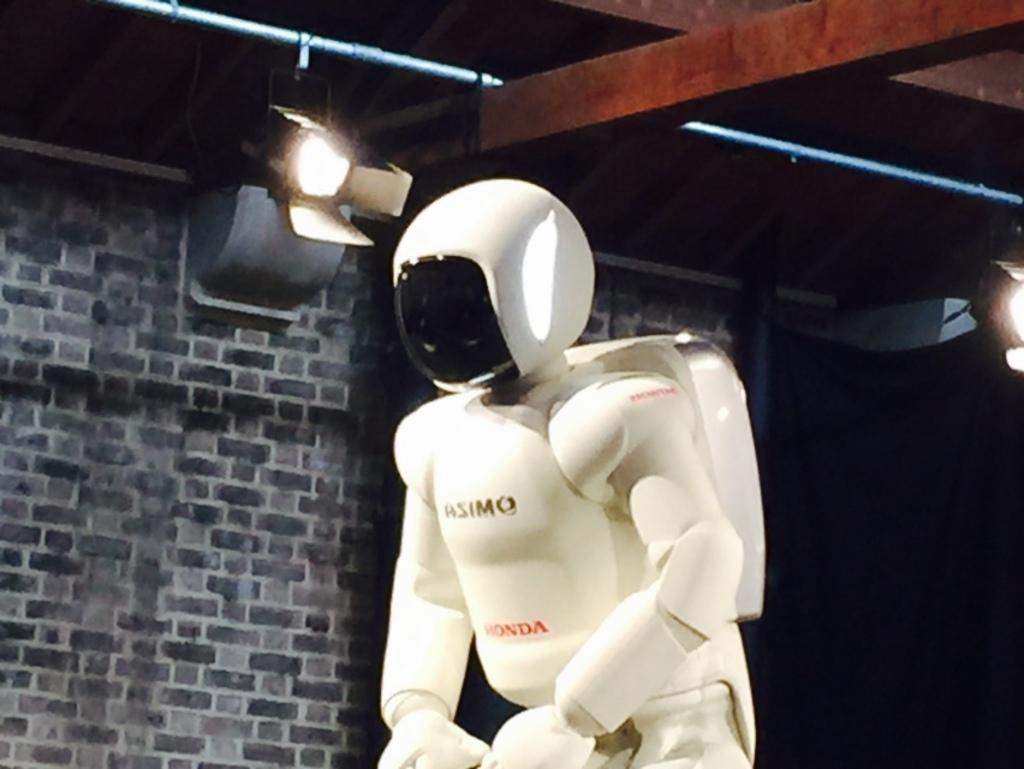What is the main subject of the image? There is a white color robot in the image. Where is the robot located in the image? The robot is in the middle of the image. What can be seen in the background of the image? There is a wall in the background of the image. What is the source of light in the image? There is a light at the top of the image. What type of vegetable is being stored on the shelf in the image? There is no shelf or vegetable present in the image. 